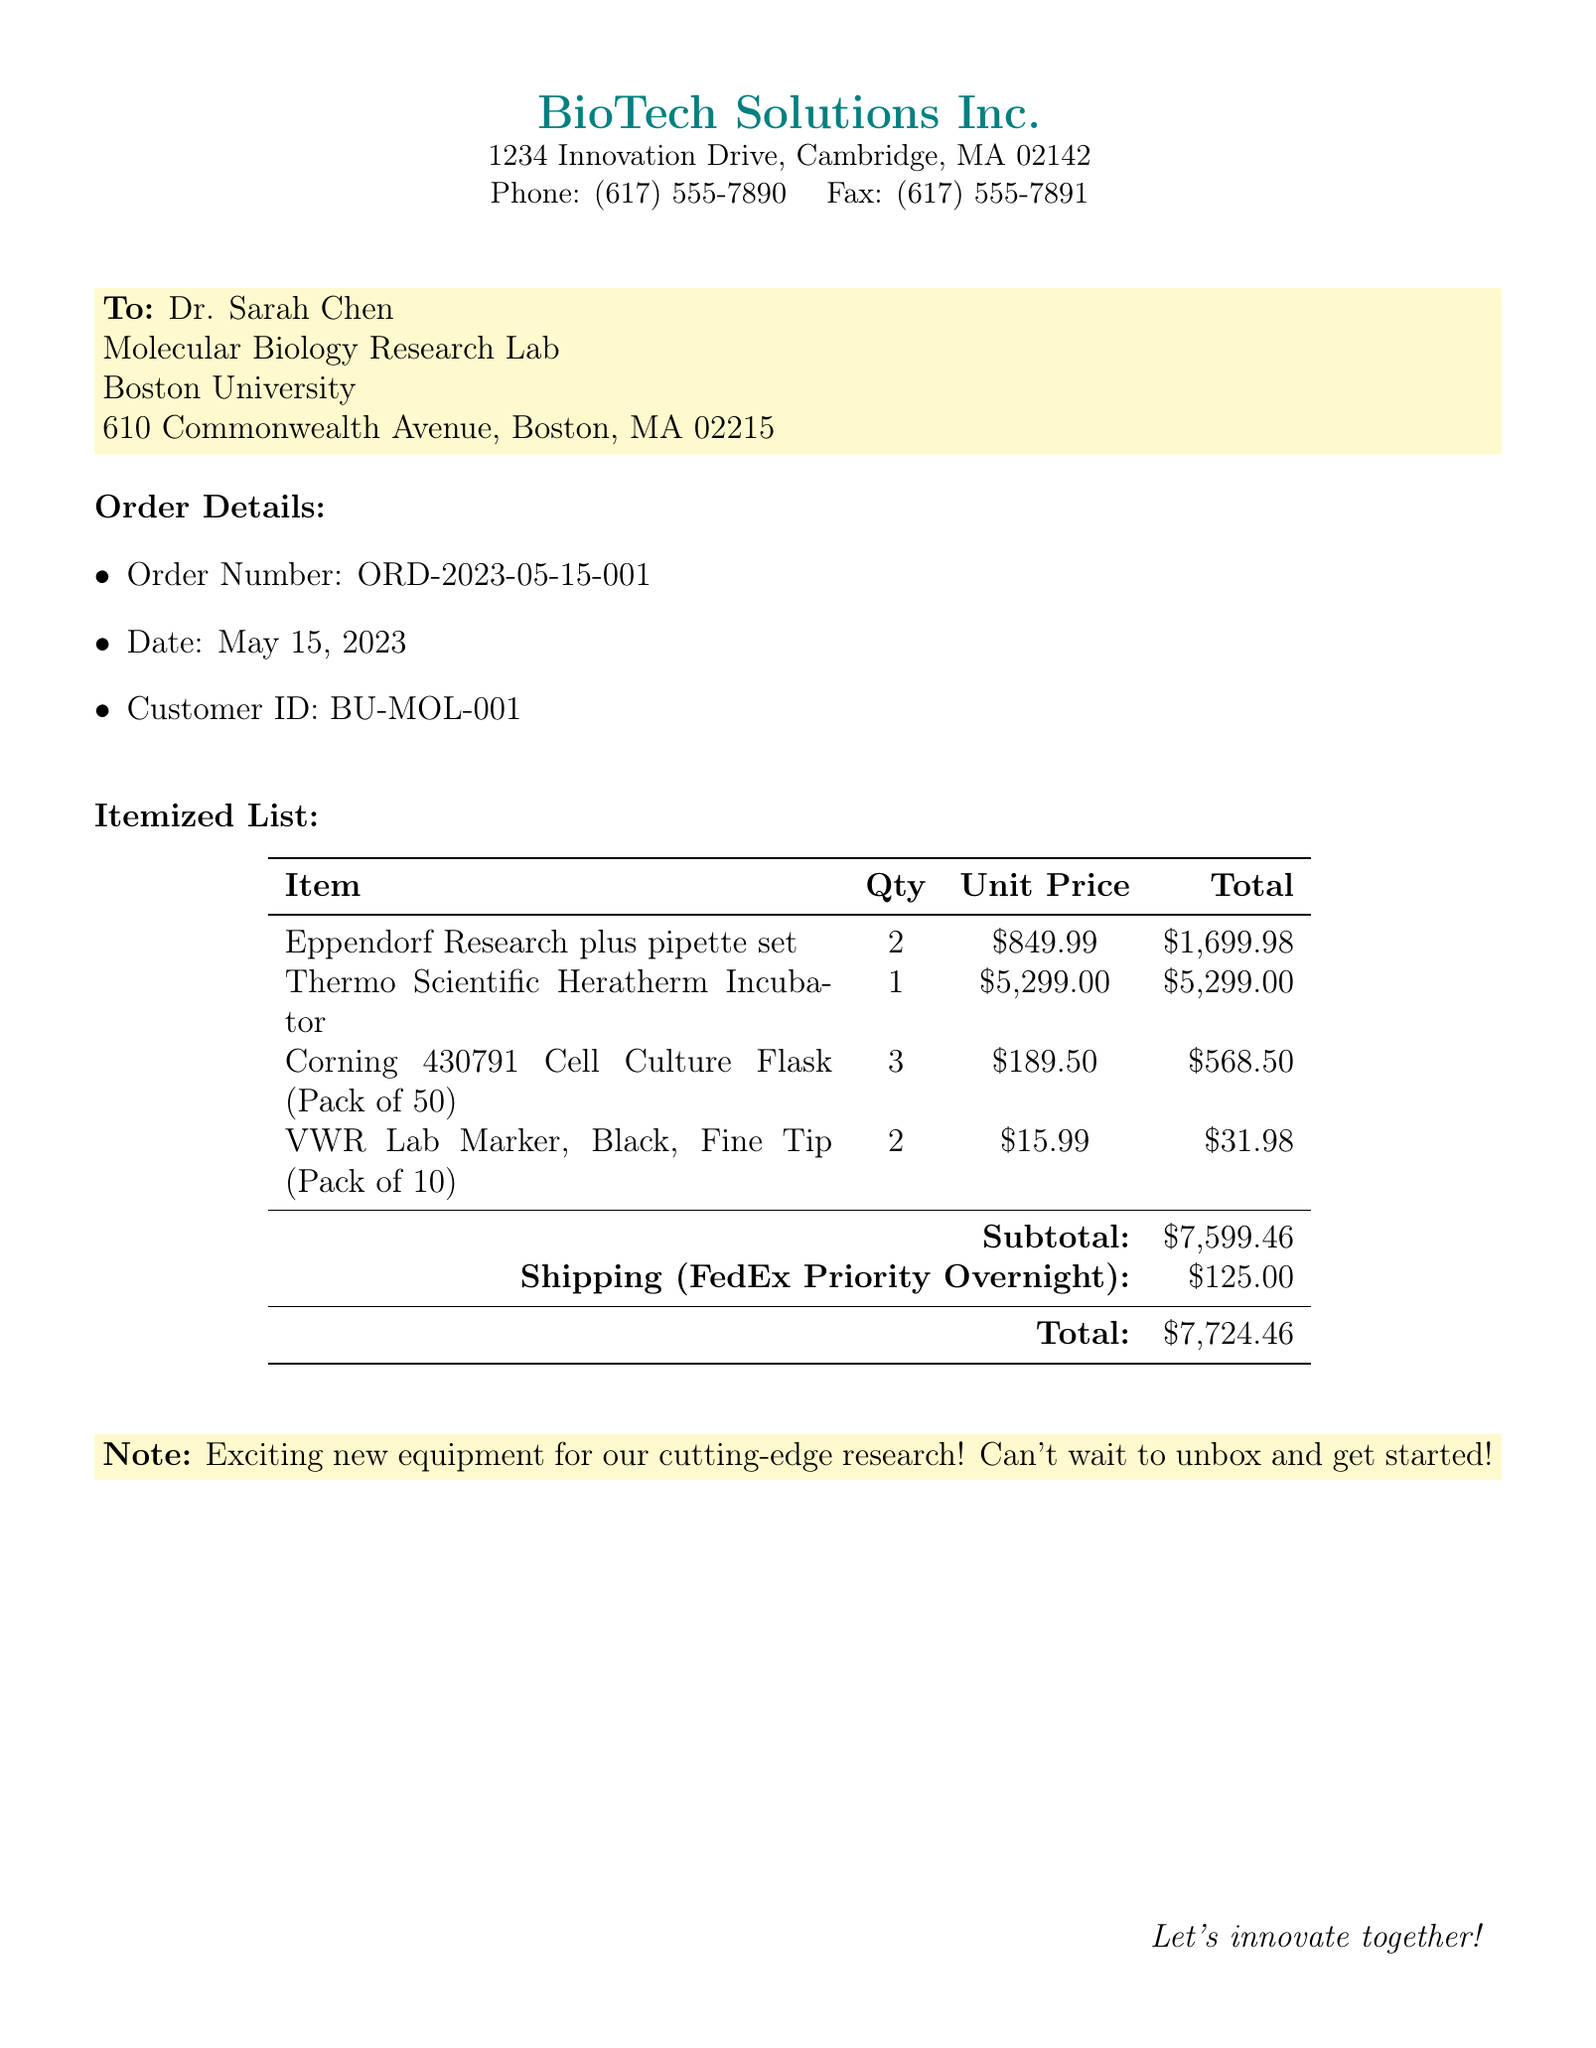What is the order number? The order number is clearly mentioned in the order details section.
Answer: ORD-2023-05-15-001 What is the date of the order? The date of the order is specified in the order details section.
Answer: May 15, 2023 How many Eppendorf Research plus pipette sets were ordered? The quantity for the pipette sets can be found in the itemized list.
Answer: 2 What is the total cost for the Thermo Scientific Heratherm Incubator? The total cost for the incubator is shown in the itemized list under total.
Answer: $5,299.00 What is the subtotal amount before shipping? The subtotal is indicated in the itemized list just before shipping costs.
Answer: $7,599.46 What is the shipping method used? The shipping method is mentioned in the itemized list under shipping.
Answer: FedEx Priority Overnight Which item has the highest unit price? The unit prices are listed in the itemized table; the item with the highest price can be identified from there.
Answer: Thermo Scientific Heratherm Incubator What does the note indicate about the equipment? The note highlights the excitement regarding the new equipment for research.
Answer: Exciting new equipment for our cutting-edge research! Who is the recipient of the fax? The recipient's name is listed at the beginning of the document in the "To" section.
Answer: Dr. Sarah Chen 